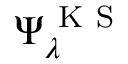Convert formula to latex. <formula><loc_0><loc_0><loc_500><loc_500>\Psi _ { \lambda } ^ { K S }</formula> 